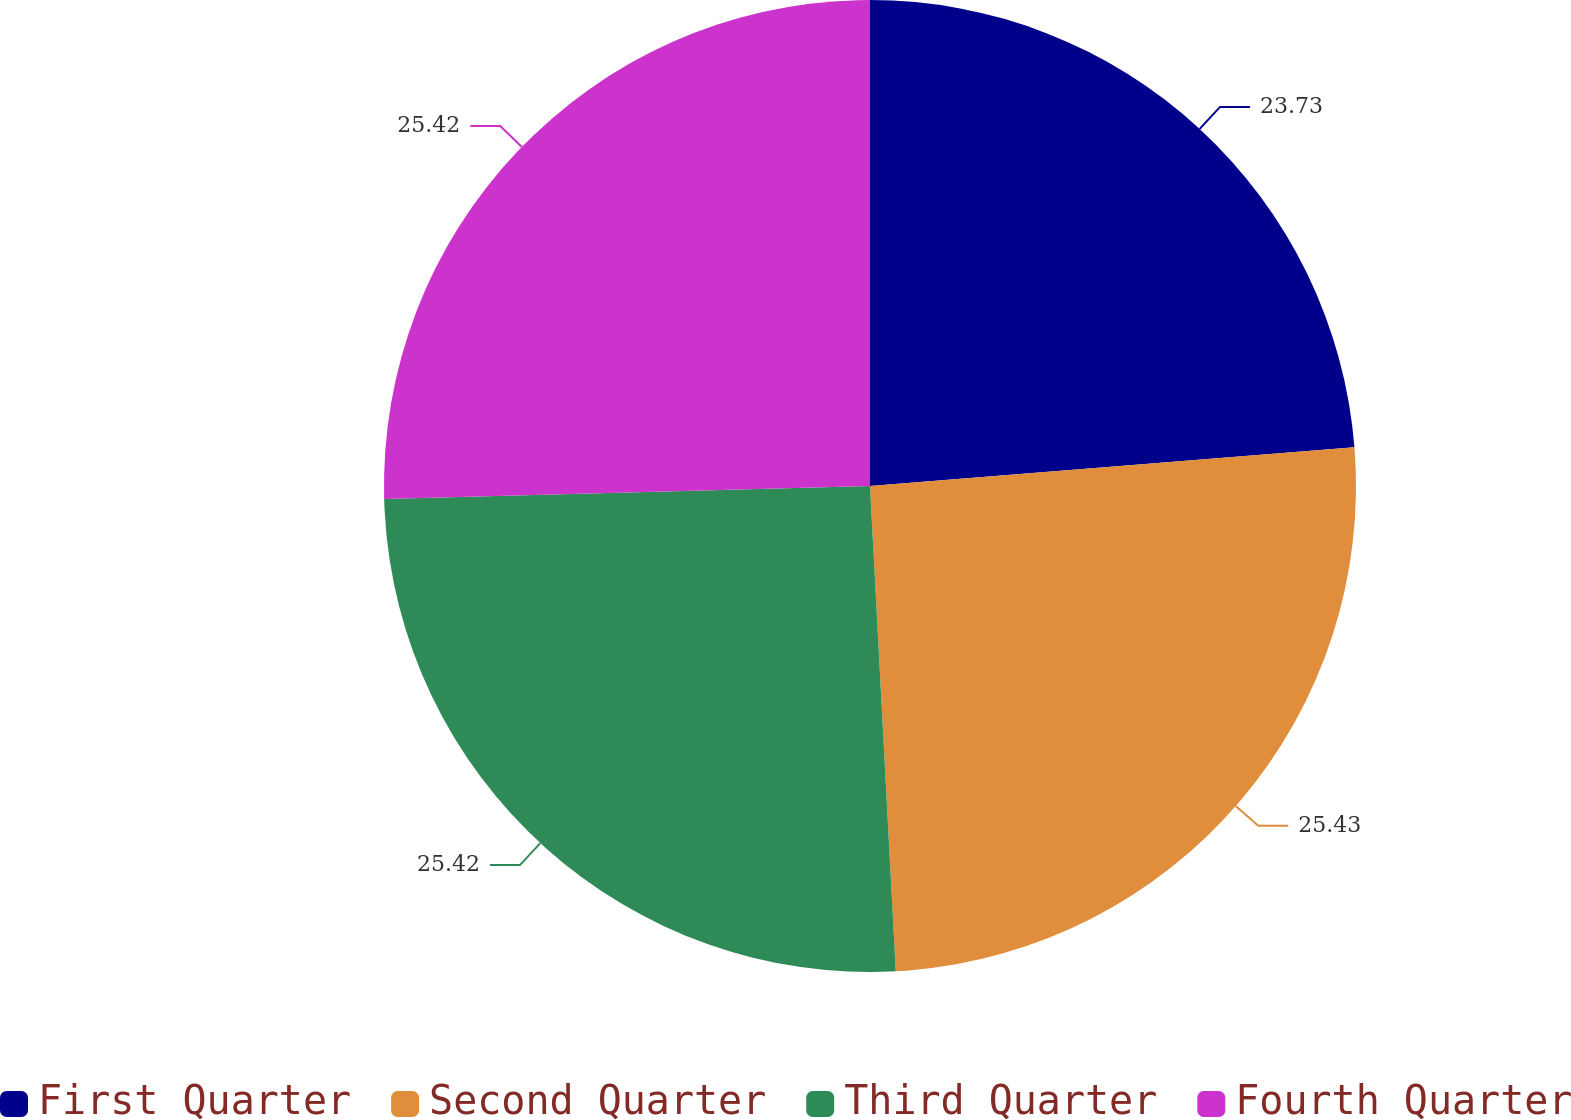Convert chart to OTSL. <chart><loc_0><loc_0><loc_500><loc_500><pie_chart><fcel>First Quarter<fcel>Second Quarter<fcel>Third Quarter<fcel>Fourth Quarter<nl><fcel>23.73%<fcel>25.42%<fcel>25.42%<fcel>25.42%<nl></chart> 